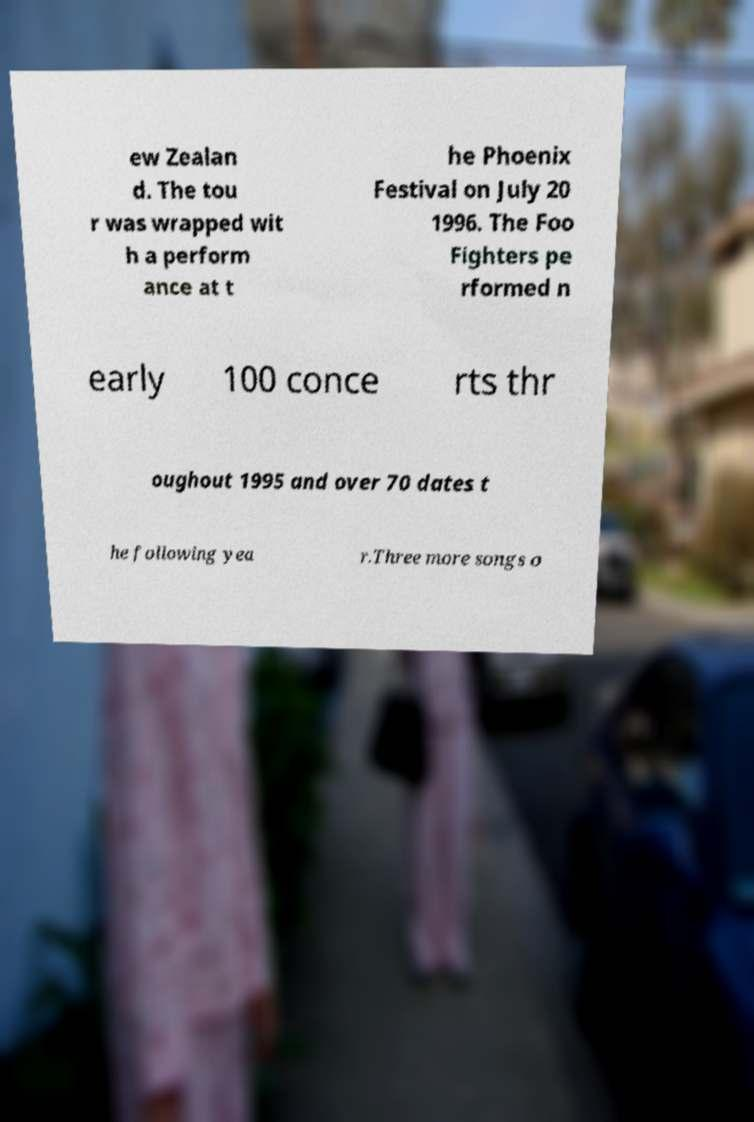There's text embedded in this image that I need extracted. Can you transcribe it verbatim? ew Zealan d. The tou r was wrapped wit h a perform ance at t he Phoenix Festival on July 20 1996. The Foo Fighters pe rformed n early 100 conce rts thr oughout 1995 and over 70 dates t he following yea r.Three more songs o 